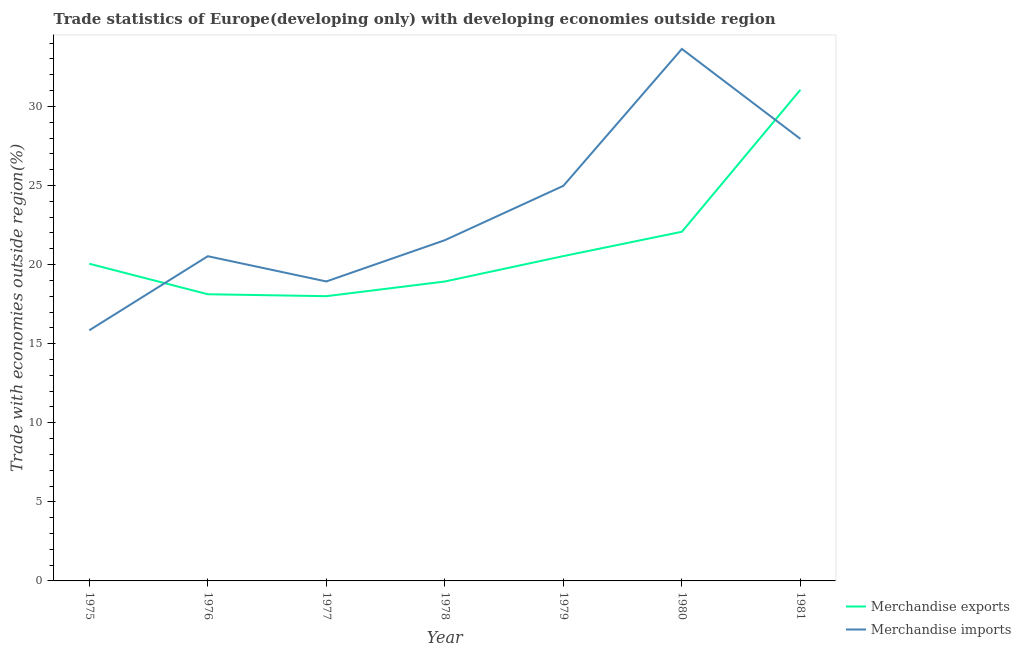How many different coloured lines are there?
Your response must be concise. 2. Is the number of lines equal to the number of legend labels?
Give a very brief answer. Yes. What is the merchandise exports in 1976?
Offer a very short reply. 18.12. Across all years, what is the maximum merchandise exports?
Offer a very short reply. 31.05. Across all years, what is the minimum merchandise exports?
Keep it short and to the point. 18. In which year was the merchandise exports minimum?
Keep it short and to the point. 1977. What is the total merchandise exports in the graph?
Make the answer very short. 148.76. What is the difference between the merchandise exports in 1979 and that in 1981?
Provide a succinct answer. -10.51. What is the difference between the merchandise imports in 1975 and the merchandise exports in 1980?
Offer a very short reply. -6.23. What is the average merchandise exports per year?
Provide a short and direct response. 21.25. In the year 1977, what is the difference between the merchandise exports and merchandise imports?
Keep it short and to the point. -0.93. What is the ratio of the merchandise exports in 1976 to that in 1977?
Provide a succinct answer. 1.01. Is the merchandise imports in 1977 less than that in 1980?
Your answer should be very brief. Yes. What is the difference between the highest and the second highest merchandise exports?
Your response must be concise. 8.98. What is the difference between the highest and the lowest merchandise exports?
Give a very brief answer. 13.05. Is the sum of the merchandise exports in 1980 and 1981 greater than the maximum merchandise imports across all years?
Offer a very short reply. Yes. Does the merchandise imports monotonically increase over the years?
Offer a terse response. No. How many lines are there?
Your answer should be compact. 2. What is the difference between two consecutive major ticks on the Y-axis?
Provide a short and direct response. 5. Where does the legend appear in the graph?
Make the answer very short. Bottom right. How are the legend labels stacked?
Offer a very short reply. Vertical. What is the title of the graph?
Provide a succinct answer. Trade statistics of Europe(developing only) with developing economies outside region. What is the label or title of the X-axis?
Give a very brief answer. Year. What is the label or title of the Y-axis?
Your response must be concise. Trade with economies outside region(%). What is the Trade with economies outside region(%) of Merchandise exports in 1975?
Offer a very short reply. 20.05. What is the Trade with economies outside region(%) in Merchandise imports in 1975?
Offer a very short reply. 15.84. What is the Trade with economies outside region(%) in Merchandise exports in 1976?
Provide a short and direct response. 18.12. What is the Trade with economies outside region(%) in Merchandise imports in 1976?
Provide a succinct answer. 20.53. What is the Trade with economies outside region(%) in Merchandise exports in 1977?
Your response must be concise. 18. What is the Trade with economies outside region(%) of Merchandise imports in 1977?
Ensure brevity in your answer.  18.93. What is the Trade with economies outside region(%) in Merchandise exports in 1978?
Provide a succinct answer. 18.93. What is the Trade with economies outside region(%) of Merchandise imports in 1978?
Ensure brevity in your answer.  21.54. What is the Trade with economies outside region(%) in Merchandise exports in 1979?
Offer a terse response. 20.54. What is the Trade with economies outside region(%) in Merchandise imports in 1979?
Ensure brevity in your answer.  24.98. What is the Trade with economies outside region(%) in Merchandise exports in 1980?
Give a very brief answer. 22.07. What is the Trade with economies outside region(%) of Merchandise imports in 1980?
Provide a short and direct response. 33.63. What is the Trade with economies outside region(%) of Merchandise exports in 1981?
Offer a terse response. 31.05. What is the Trade with economies outside region(%) in Merchandise imports in 1981?
Make the answer very short. 27.94. Across all years, what is the maximum Trade with economies outside region(%) in Merchandise exports?
Keep it short and to the point. 31.05. Across all years, what is the maximum Trade with economies outside region(%) in Merchandise imports?
Your answer should be compact. 33.63. Across all years, what is the minimum Trade with economies outside region(%) of Merchandise exports?
Make the answer very short. 18. Across all years, what is the minimum Trade with economies outside region(%) in Merchandise imports?
Ensure brevity in your answer.  15.84. What is the total Trade with economies outside region(%) of Merchandise exports in the graph?
Provide a succinct answer. 148.76. What is the total Trade with economies outside region(%) in Merchandise imports in the graph?
Make the answer very short. 163.4. What is the difference between the Trade with economies outside region(%) of Merchandise exports in 1975 and that in 1976?
Keep it short and to the point. 1.93. What is the difference between the Trade with economies outside region(%) of Merchandise imports in 1975 and that in 1976?
Offer a terse response. -4.68. What is the difference between the Trade with economies outside region(%) of Merchandise exports in 1975 and that in 1977?
Ensure brevity in your answer.  2.05. What is the difference between the Trade with economies outside region(%) in Merchandise imports in 1975 and that in 1977?
Provide a short and direct response. -3.09. What is the difference between the Trade with economies outside region(%) in Merchandise exports in 1975 and that in 1978?
Your answer should be very brief. 1.12. What is the difference between the Trade with economies outside region(%) of Merchandise imports in 1975 and that in 1978?
Give a very brief answer. -5.7. What is the difference between the Trade with economies outside region(%) in Merchandise exports in 1975 and that in 1979?
Your response must be concise. -0.48. What is the difference between the Trade with economies outside region(%) in Merchandise imports in 1975 and that in 1979?
Give a very brief answer. -9.13. What is the difference between the Trade with economies outside region(%) of Merchandise exports in 1975 and that in 1980?
Make the answer very short. -2.02. What is the difference between the Trade with economies outside region(%) in Merchandise imports in 1975 and that in 1980?
Provide a short and direct response. -17.79. What is the difference between the Trade with economies outside region(%) in Merchandise exports in 1975 and that in 1981?
Ensure brevity in your answer.  -11. What is the difference between the Trade with economies outside region(%) in Merchandise imports in 1975 and that in 1981?
Offer a very short reply. -12.1. What is the difference between the Trade with economies outside region(%) of Merchandise exports in 1976 and that in 1977?
Make the answer very short. 0.12. What is the difference between the Trade with economies outside region(%) in Merchandise imports in 1976 and that in 1977?
Your response must be concise. 1.6. What is the difference between the Trade with economies outside region(%) of Merchandise exports in 1976 and that in 1978?
Provide a short and direct response. -0.81. What is the difference between the Trade with economies outside region(%) in Merchandise imports in 1976 and that in 1978?
Keep it short and to the point. -1.01. What is the difference between the Trade with economies outside region(%) of Merchandise exports in 1976 and that in 1979?
Provide a succinct answer. -2.41. What is the difference between the Trade with economies outside region(%) of Merchandise imports in 1976 and that in 1979?
Provide a short and direct response. -4.45. What is the difference between the Trade with economies outside region(%) in Merchandise exports in 1976 and that in 1980?
Your answer should be compact. -3.95. What is the difference between the Trade with economies outside region(%) of Merchandise imports in 1976 and that in 1980?
Your response must be concise. -13.1. What is the difference between the Trade with economies outside region(%) of Merchandise exports in 1976 and that in 1981?
Your answer should be very brief. -12.93. What is the difference between the Trade with economies outside region(%) in Merchandise imports in 1976 and that in 1981?
Make the answer very short. -7.42. What is the difference between the Trade with economies outside region(%) in Merchandise exports in 1977 and that in 1978?
Offer a very short reply. -0.93. What is the difference between the Trade with economies outside region(%) in Merchandise imports in 1977 and that in 1978?
Your response must be concise. -2.61. What is the difference between the Trade with economies outside region(%) in Merchandise exports in 1977 and that in 1979?
Your answer should be very brief. -2.53. What is the difference between the Trade with economies outside region(%) in Merchandise imports in 1977 and that in 1979?
Your response must be concise. -6.05. What is the difference between the Trade with economies outside region(%) of Merchandise exports in 1977 and that in 1980?
Your answer should be very brief. -4.07. What is the difference between the Trade with economies outside region(%) in Merchandise imports in 1977 and that in 1980?
Keep it short and to the point. -14.7. What is the difference between the Trade with economies outside region(%) of Merchandise exports in 1977 and that in 1981?
Your answer should be compact. -13.05. What is the difference between the Trade with economies outside region(%) in Merchandise imports in 1977 and that in 1981?
Offer a very short reply. -9.01. What is the difference between the Trade with economies outside region(%) in Merchandise exports in 1978 and that in 1979?
Ensure brevity in your answer.  -1.61. What is the difference between the Trade with economies outside region(%) of Merchandise imports in 1978 and that in 1979?
Make the answer very short. -3.44. What is the difference between the Trade with economies outside region(%) in Merchandise exports in 1978 and that in 1980?
Give a very brief answer. -3.14. What is the difference between the Trade with economies outside region(%) of Merchandise imports in 1978 and that in 1980?
Offer a terse response. -12.09. What is the difference between the Trade with economies outside region(%) of Merchandise exports in 1978 and that in 1981?
Offer a very short reply. -12.12. What is the difference between the Trade with economies outside region(%) in Merchandise imports in 1978 and that in 1981?
Provide a short and direct response. -6.4. What is the difference between the Trade with economies outside region(%) of Merchandise exports in 1979 and that in 1980?
Offer a terse response. -1.54. What is the difference between the Trade with economies outside region(%) in Merchandise imports in 1979 and that in 1980?
Make the answer very short. -8.65. What is the difference between the Trade with economies outside region(%) in Merchandise exports in 1979 and that in 1981?
Provide a short and direct response. -10.51. What is the difference between the Trade with economies outside region(%) of Merchandise imports in 1979 and that in 1981?
Your answer should be compact. -2.97. What is the difference between the Trade with economies outside region(%) in Merchandise exports in 1980 and that in 1981?
Keep it short and to the point. -8.98. What is the difference between the Trade with economies outside region(%) in Merchandise imports in 1980 and that in 1981?
Keep it short and to the point. 5.69. What is the difference between the Trade with economies outside region(%) in Merchandise exports in 1975 and the Trade with economies outside region(%) in Merchandise imports in 1976?
Provide a short and direct response. -0.48. What is the difference between the Trade with economies outside region(%) in Merchandise exports in 1975 and the Trade with economies outside region(%) in Merchandise imports in 1977?
Ensure brevity in your answer.  1.12. What is the difference between the Trade with economies outside region(%) of Merchandise exports in 1975 and the Trade with economies outside region(%) of Merchandise imports in 1978?
Keep it short and to the point. -1.49. What is the difference between the Trade with economies outside region(%) in Merchandise exports in 1975 and the Trade with economies outside region(%) in Merchandise imports in 1979?
Your answer should be compact. -4.93. What is the difference between the Trade with economies outside region(%) of Merchandise exports in 1975 and the Trade with economies outside region(%) of Merchandise imports in 1980?
Give a very brief answer. -13.58. What is the difference between the Trade with economies outside region(%) in Merchandise exports in 1975 and the Trade with economies outside region(%) in Merchandise imports in 1981?
Ensure brevity in your answer.  -7.89. What is the difference between the Trade with economies outside region(%) of Merchandise exports in 1976 and the Trade with economies outside region(%) of Merchandise imports in 1977?
Make the answer very short. -0.81. What is the difference between the Trade with economies outside region(%) of Merchandise exports in 1976 and the Trade with economies outside region(%) of Merchandise imports in 1978?
Your answer should be very brief. -3.42. What is the difference between the Trade with economies outside region(%) of Merchandise exports in 1976 and the Trade with economies outside region(%) of Merchandise imports in 1979?
Keep it short and to the point. -6.85. What is the difference between the Trade with economies outside region(%) of Merchandise exports in 1976 and the Trade with economies outside region(%) of Merchandise imports in 1980?
Offer a very short reply. -15.51. What is the difference between the Trade with economies outside region(%) in Merchandise exports in 1976 and the Trade with economies outside region(%) in Merchandise imports in 1981?
Make the answer very short. -9.82. What is the difference between the Trade with economies outside region(%) of Merchandise exports in 1977 and the Trade with economies outside region(%) of Merchandise imports in 1978?
Provide a succinct answer. -3.54. What is the difference between the Trade with economies outside region(%) of Merchandise exports in 1977 and the Trade with economies outside region(%) of Merchandise imports in 1979?
Provide a short and direct response. -6.98. What is the difference between the Trade with economies outside region(%) in Merchandise exports in 1977 and the Trade with economies outside region(%) in Merchandise imports in 1980?
Your answer should be very brief. -15.63. What is the difference between the Trade with economies outside region(%) in Merchandise exports in 1977 and the Trade with economies outside region(%) in Merchandise imports in 1981?
Your answer should be very brief. -9.94. What is the difference between the Trade with economies outside region(%) of Merchandise exports in 1978 and the Trade with economies outside region(%) of Merchandise imports in 1979?
Ensure brevity in your answer.  -6.05. What is the difference between the Trade with economies outside region(%) of Merchandise exports in 1978 and the Trade with economies outside region(%) of Merchandise imports in 1980?
Make the answer very short. -14.7. What is the difference between the Trade with economies outside region(%) of Merchandise exports in 1978 and the Trade with economies outside region(%) of Merchandise imports in 1981?
Offer a very short reply. -9.02. What is the difference between the Trade with economies outside region(%) of Merchandise exports in 1979 and the Trade with economies outside region(%) of Merchandise imports in 1980?
Your answer should be compact. -13.1. What is the difference between the Trade with economies outside region(%) of Merchandise exports in 1979 and the Trade with economies outside region(%) of Merchandise imports in 1981?
Offer a terse response. -7.41. What is the difference between the Trade with economies outside region(%) of Merchandise exports in 1980 and the Trade with economies outside region(%) of Merchandise imports in 1981?
Your answer should be very brief. -5.87. What is the average Trade with economies outside region(%) in Merchandise exports per year?
Your answer should be very brief. 21.25. What is the average Trade with economies outside region(%) of Merchandise imports per year?
Make the answer very short. 23.34. In the year 1975, what is the difference between the Trade with economies outside region(%) of Merchandise exports and Trade with economies outside region(%) of Merchandise imports?
Your answer should be very brief. 4.21. In the year 1976, what is the difference between the Trade with economies outside region(%) in Merchandise exports and Trade with economies outside region(%) in Merchandise imports?
Offer a terse response. -2.4. In the year 1977, what is the difference between the Trade with economies outside region(%) of Merchandise exports and Trade with economies outside region(%) of Merchandise imports?
Keep it short and to the point. -0.93. In the year 1978, what is the difference between the Trade with economies outside region(%) in Merchandise exports and Trade with economies outside region(%) in Merchandise imports?
Your answer should be very brief. -2.61. In the year 1979, what is the difference between the Trade with economies outside region(%) of Merchandise exports and Trade with economies outside region(%) of Merchandise imports?
Your response must be concise. -4.44. In the year 1980, what is the difference between the Trade with economies outside region(%) in Merchandise exports and Trade with economies outside region(%) in Merchandise imports?
Your answer should be very brief. -11.56. In the year 1981, what is the difference between the Trade with economies outside region(%) of Merchandise exports and Trade with economies outside region(%) of Merchandise imports?
Your answer should be compact. 3.11. What is the ratio of the Trade with economies outside region(%) of Merchandise exports in 1975 to that in 1976?
Make the answer very short. 1.11. What is the ratio of the Trade with economies outside region(%) in Merchandise imports in 1975 to that in 1976?
Your answer should be very brief. 0.77. What is the ratio of the Trade with economies outside region(%) of Merchandise exports in 1975 to that in 1977?
Provide a short and direct response. 1.11. What is the ratio of the Trade with economies outside region(%) in Merchandise imports in 1975 to that in 1977?
Offer a very short reply. 0.84. What is the ratio of the Trade with economies outside region(%) in Merchandise exports in 1975 to that in 1978?
Offer a terse response. 1.06. What is the ratio of the Trade with economies outside region(%) in Merchandise imports in 1975 to that in 1978?
Provide a succinct answer. 0.74. What is the ratio of the Trade with economies outside region(%) of Merchandise exports in 1975 to that in 1979?
Provide a succinct answer. 0.98. What is the ratio of the Trade with economies outside region(%) of Merchandise imports in 1975 to that in 1979?
Your response must be concise. 0.63. What is the ratio of the Trade with economies outside region(%) in Merchandise exports in 1975 to that in 1980?
Offer a terse response. 0.91. What is the ratio of the Trade with economies outside region(%) of Merchandise imports in 1975 to that in 1980?
Make the answer very short. 0.47. What is the ratio of the Trade with economies outside region(%) in Merchandise exports in 1975 to that in 1981?
Give a very brief answer. 0.65. What is the ratio of the Trade with economies outside region(%) in Merchandise imports in 1975 to that in 1981?
Give a very brief answer. 0.57. What is the ratio of the Trade with economies outside region(%) in Merchandise exports in 1976 to that in 1977?
Give a very brief answer. 1.01. What is the ratio of the Trade with economies outside region(%) of Merchandise imports in 1976 to that in 1977?
Give a very brief answer. 1.08. What is the ratio of the Trade with economies outside region(%) in Merchandise exports in 1976 to that in 1978?
Offer a terse response. 0.96. What is the ratio of the Trade with economies outside region(%) in Merchandise imports in 1976 to that in 1978?
Your response must be concise. 0.95. What is the ratio of the Trade with economies outside region(%) of Merchandise exports in 1976 to that in 1979?
Provide a succinct answer. 0.88. What is the ratio of the Trade with economies outside region(%) in Merchandise imports in 1976 to that in 1979?
Give a very brief answer. 0.82. What is the ratio of the Trade with economies outside region(%) of Merchandise exports in 1976 to that in 1980?
Your response must be concise. 0.82. What is the ratio of the Trade with economies outside region(%) of Merchandise imports in 1976 to that in 1980?
Provide a succinct answer. 0.61. What is the ratio of the Trade with economies outside region(%) in Merchandise exports in 1976 to that in 1981?
Offer a terse response. 0.58. What is the ratio of the Trade with economies outside region(%) of Merchandise imports in 1976 to that in 1981?
Provide a short and direct response. 0.73. What is the ratio of the Trade with economies outside region(%) of Merchandise exports in 1977 to that in 1978?
Provide a succinct answer. 0.95. What is the ratio of the Trade with economies outside region(%) of Merchandise imports in 1977 to that in 1978?
Offer a very short reply. 0.88. What is the ratio of the Trade with economies outside region(%) in Merchandise exports in 1977 to that in 1979?
Your response must be concise. 0.88. What is the ratio of the Trade with economies outside region(%) in Merchandise imports in 1977 to that in 1979?
Provide a succinct answer. 0.76. What is the ratio of the Trade with economies outside region(%) of Merchandise exports in 1977 to that in 1980?
Your answer should be very brief. 0.82. What is the ratio of the Trade with economies outside region(%) of Merchandise imports in 1977 to that in 1980?
Your answer should be very brief. 0.56. What is the ratio of the Trade with economies outside region(%) of Merchandise exports in 1977 to that in 1981?
Your answer should be very brief. 0.58. What is the ratio of the Trade with economies outside region(%) in Merchandise imports in 1977 to that in 1981?
Make the answer very short. 0.68. What is the ratio of the Trade with economies outside region(%) of Merchandise exports in 1978 to that in 1979?
Provide a short and direct response. 0.92. What is the ratio of the Trade with economies outside region(%) in Merchandise imports in 1978 to that in 1979?
Your answer should be very brief. 0.86. What is the ratio of the Trade with economies outside region(%) in Merchandise exports in 1978 to that in 1980?
Make the answer very short. 0.86. What is the ratio of the Trade with economies outside region(%) in Merchandise imports in 1978 to that in 1980?
Offer a terse response. 0.64. What is the ratio of the Trade with economies outside region(%) of Merchandise exports in 1978 to that in 1981?
Keep it short and to the point. 0.61. What is the ratio of the Trade with economies outside region(%) in Merchandise imports in 1978 to that in 1981?
Your answer should be very brief. 0.77. What is the ratio of the Trade with economies outside region(%) in Merchandise exports in 1979 to that in 1980?
Offer a very short reply. 0.93. What is the ratio of the Trade with economies outside region(%) in Merchandise imports in 1979 to that in 1980?
Your answer should be very brief. 0.74. What is the ratio of the Trade with economies outside region(%) of Merchandise exports in 1979 to that in 1981?
Offer a terse response. 0.66. What is the ratio of the Trade with economies outside region(%) in Merchandise imports in 1979 to that in 1981?
Offer a terse response. 0.89. What is the ratio of the Trade with economies outside region(%) in Merchandise exports in 1980 to that in 1981?
Provide a succinct answer. 0.71. What is the ratio of the Trade with economies outside region(%) in Merchandise imports in 1980 to that in 1981?
Your answer should be compact. 1.2. What is the difference between the highest and the second highest Trade with economies outside region(%) of Merchandise exports?
Ensure brevity in your answer.  8.98. What is the difference between the highest and the second highest Trade with economies outside region(%) in Merchandise imports?
Provide a short and direct response. 5.69. What is the difference between the highest and the lowest Trade with economies outside region(%) of Merchandise exports?
Your response must be concise. 13.05. What is the difference between the highest and the lowest Trade with economies outside region(%) of Merchandise imports?
Give a very brief answer. 17.79. 